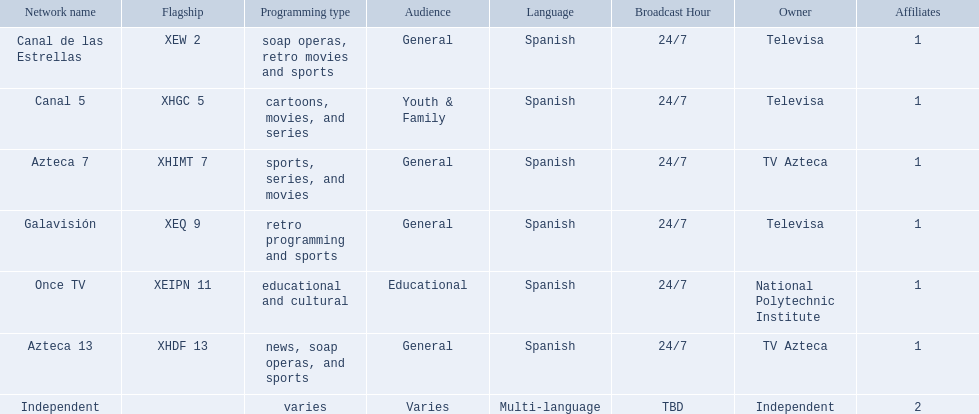Which owner only owns one network? National Polytechnic Institute, Independent. Of those, what is the network name? Once TV, Independent. Of those, which programming type is educational and cultural? Once TV. 